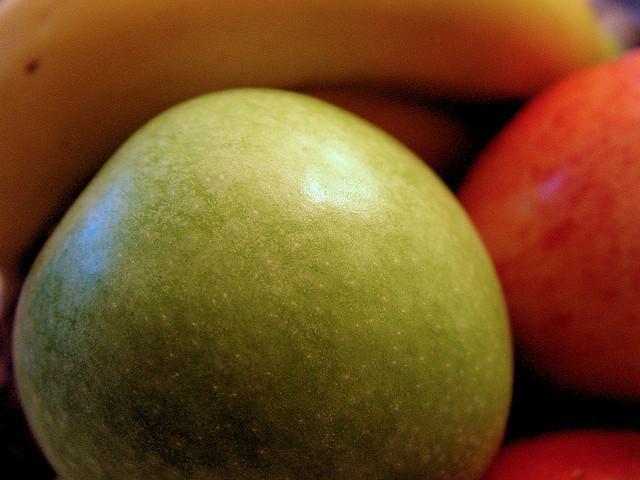How many different fruits can be seen?
Give a very brief answer. 3. How many apples are there?
Give a very brief answer. 3. 